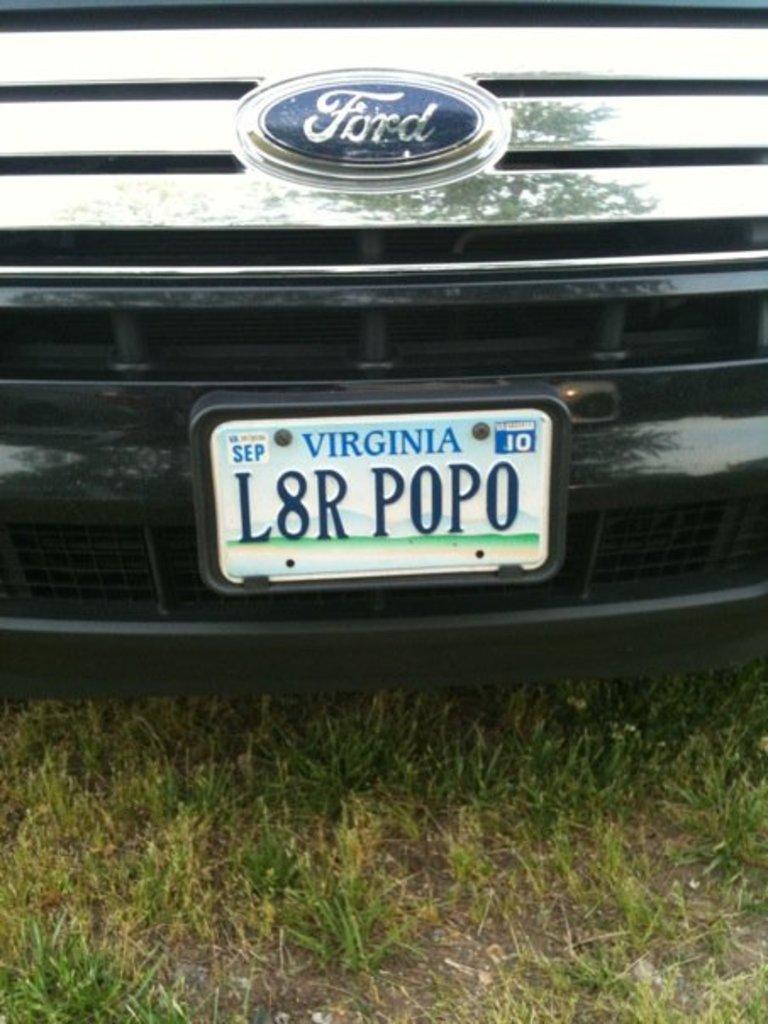Where is this plate registered?
Make the answer very short. Virginia. What year does the tag expire?
Offer a terse response. 2010. 